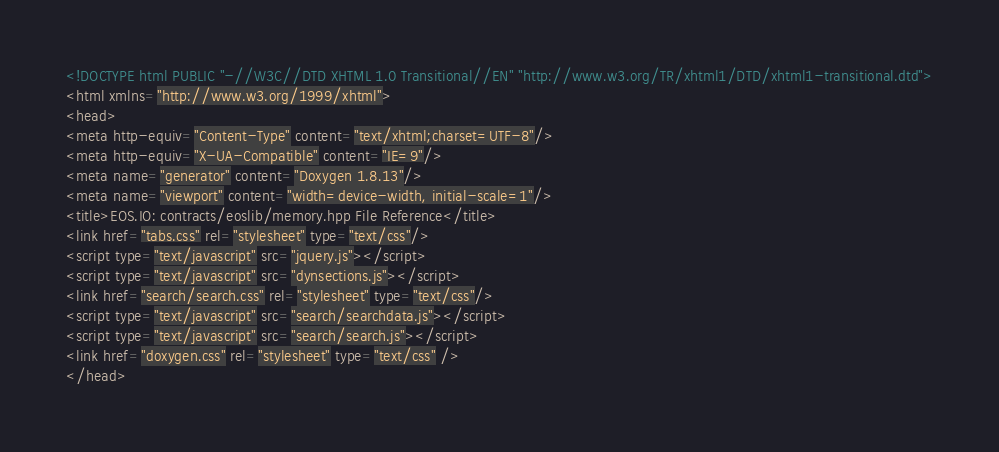Convert code to text. <code><loc_0><loc_0><loc_500><loc_500><_HTML_><!DOCTYPE html PUBLIC "-//W3C//DTD XHTML 1.0 Transitional//EN" "http://www.w3.org/TR/xhtml1/DTD/xhtml1-transitional.dtd">
<html xmlns="http://www.w3.org/1999/xhtml">
<head>
<meta http-equiv="Content-Type" content="text/xhtml;charset=UTF-8"/>
<meta http-equiv="X-UA-Compatible" content="IE=9"/>
<meta name="generator" content="Doxygen 1.8.13"/>
<meta name="viewport" content="width=device-width, initial-scale=1"/>
<title>EOS.IO: contracts/eoslib/memory.hpp File Reference</title>
<link href="tabs.css" rel="stylesheet" type="text/css"/>
<script type="text/javascript" src="jquery.js"></script>
<script type="text/javascript" src="dynsections.js"></script>
<link href="search/search.css" rel="stylesheet" type="text/css"/>
<script type="text/javascript" src="search/searchdata.js"></script>
<script type="text/javascript" src="search/search.js"></script>
<link href="doxygen.css" rel="stylesheet" type="text/css" />
</head></code> 